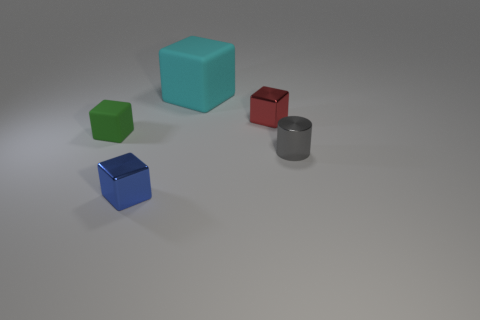Subtract all blue cubes. How many cubes are left? 3 Add 5 metal cylinders. How many objects exist? 10 Subtract all blue blocks. How many blocks are left? 3 Subtract 1 cylinders. How many cylinders are left? 0 Subtract 1 gray cylinders. How many objects are left? 4 Subtract all cylinders. How many objects are left? 4 Subtract all purple cylinders. Subtract all purple balls. How many cylinders are left? 1 Subtract all big rubber blocks. Subtract all small metallic cylinders. How many objects are left? 3 Add 3 red metallic cubes. How many red metallic cubes are left? 4 Add 5 brown rubber cylinders. How many brown rubber cylinders exist? 5 